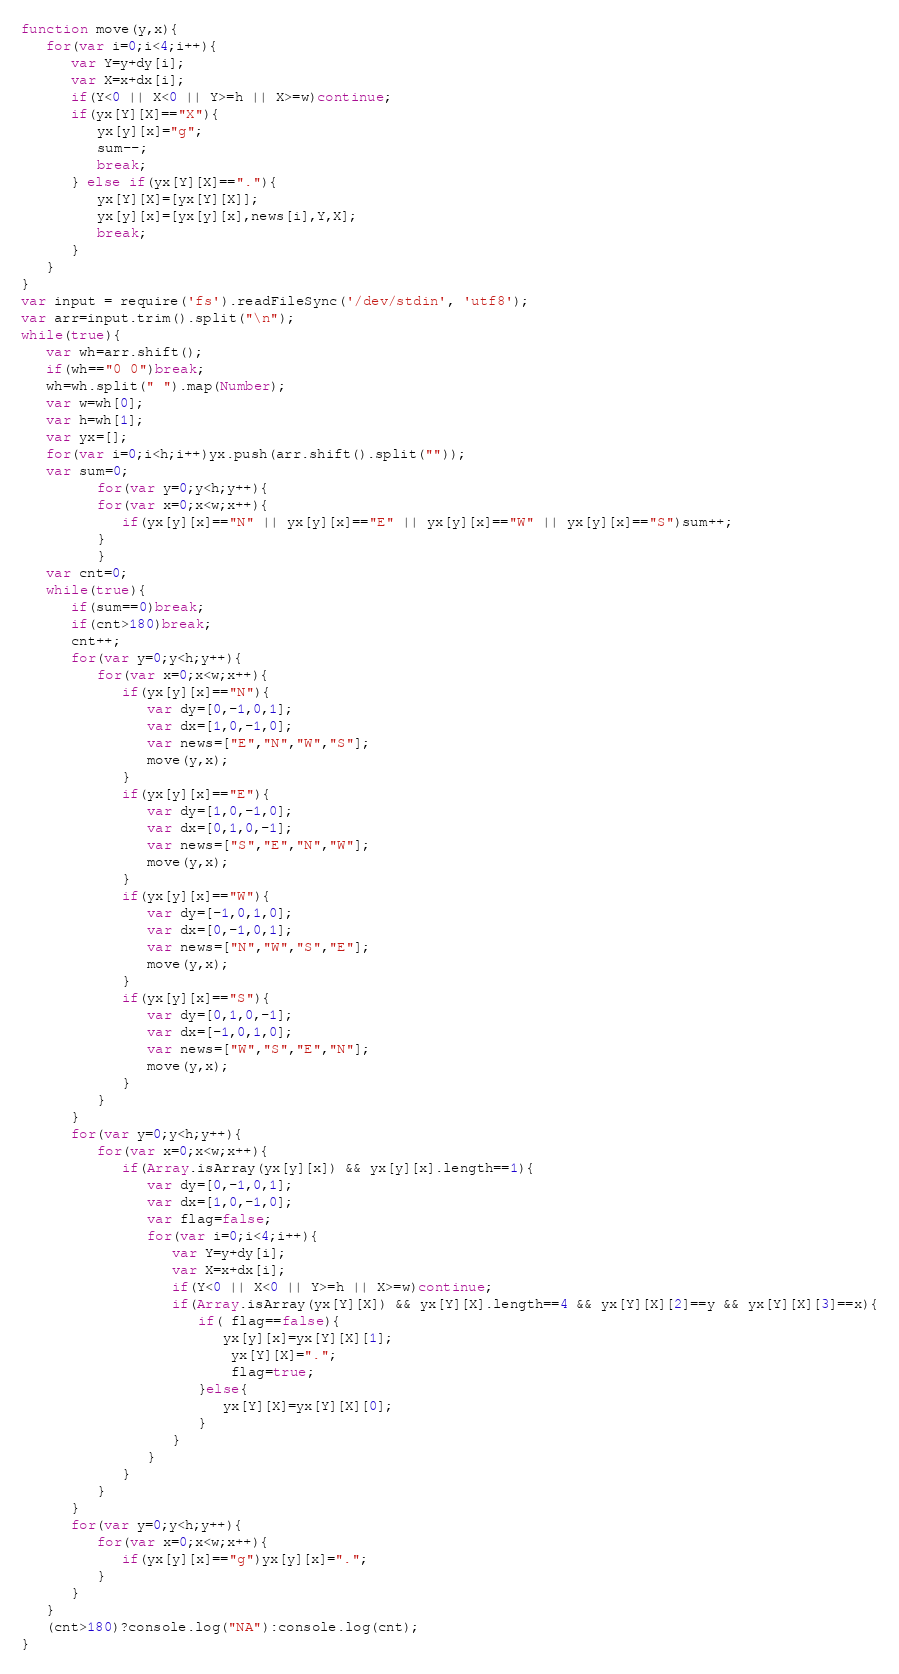Convert code to text. <code><loc_0><loc_0><loc_500><loc_500><_JavaScript_>function move(y,x){
   for(var i=0;i<4;i++){
      var Y=y+dy[i];
      var X=x+dx[i];
      if(Y<0 || X<0 || Y>=h || X>=w)continue;
      if(yx[Y][X]=="X"){
         yx[y][x]="g";
         sum--;
         break;
      } else if(yx[Y][X]=="."){
         yx[Y][X]=[yx[Y][X]];
         yx[y][x]=[yx[y][x],news[i],Y,X];
         break;
      }
   }
}
var input = require('fs').readFileSync('/dev/stdin', 'utf8');
var arr=input.trim().split("\n");
while(true){
   var wh=arr.shift();
   if(wh=="0 0")break;
   wh=wh.split(" ").map(Number);
   var w=wh[0];
   var h=wh[1];
   var yx=[];
   for(var i=0;i<h;i++)yx.push(arr.shift().split(""));
   var sum=0;
         for(var y=0;y<h;y++){
         for(var x=0;x<w;x++){
            if(yx[y][x]=="N" || yx[y][x]=="E" || yx[y][x]=="W" || yx[y][x]=="S")sum++;
         }
         }
   var cnt=0;
   while(true){
      if(sum==0)break;
      if(cnt>180)break;
      cnt++;
      for(var y=0;y<h;y++){
         for(var x=0;x<w;x++){
            if(yx[y][x]=="N"){
               var dy=[0,-1,0,1];
               var dx=[1,0,-1,0];
               var news=["E","N","W","S"];
               move(y,x);
            }
            if(yx[y][x]=="E"){
               var dy=[1,0,-1,0];
               var dx=[0,1,0,-1];
               var news=["S","E","N","W"];
               move(y,x);
            }
            if(yx[y][x]=="W"){
               var dy=[-1,0,1,0];
               var dx=[0,-1,0,1];
               var news=["N","W","S","E"];
               move(y,x);
            }
            if(yx[y][x]=="S"){
               var dy=[0,1,0,-1];
               var dx=[-1,0,1,0];
               var news=["W","S","E","N"];
               move(y,x);
            }
         }
      }
      for(var y=0;y<h;y++){
         for(var x=0;x<w;x++){
            if(Array.isArray(yx[y][x]) && yx[y][x].length==1){
               var dy=[0,-1,0,1];
               var dx=[1,0,-1,0];
               var flag=false;
               for(var i=0;i<4;i++){
                  var Y=y+dy[i];
                  var X=x+dx[i];
                  if(Y<0 || X<0 || Y>=h || X>=w)continue;
                  if(Array.isArray(yx[Y][X]) && yx[Y][X].length==4 && yx[Y][X][2]==y && yx[Y][X][3]==x){
                     if( flag==false){
                        yx[y][x]=yx[Y][X][1];
                         yx[Y][X]=".";
                         flag=true;
                     }else{
                        yx[Y][X]=yx[Y][X][0];
                     }
                  }
               }
            }
         }
      }
      for(var y=0;y<h;y++){
         for(var x=0;x<w;x++){
            if(yx[y][x]=="g")yx[y][x]=".";
         }
      }      
   }
   (cnt>180)?console.log("NA"):console.log(cnt);
}</code> 